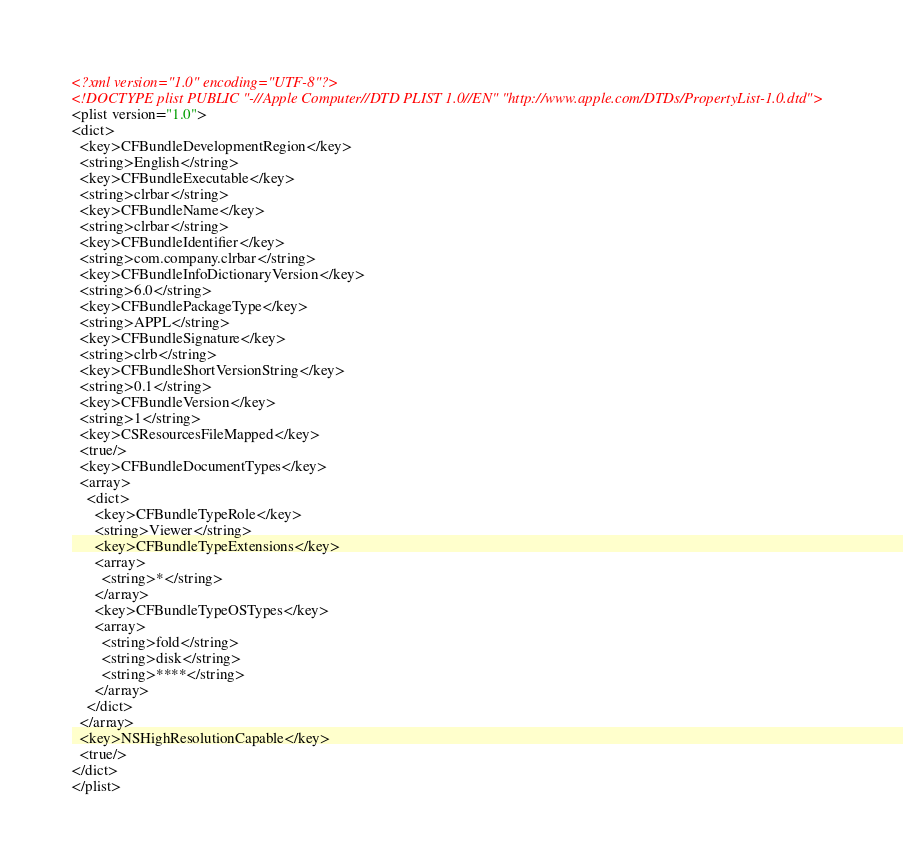Convert code to text. <code><loc_0><loc_0><loc_500><loc_500><_XML_><?xml version="1.0" encoding="UTF-8"?>
<!DOCTYPE plist PUBLIC "-//Apple Computer//DTD PLIST 1.0//EN" "http://www.apple.com/DTDs/PropertyList-1.0.dtd">
<plist version="1.0">
<dict>
  <key>CFBundleDevelopmentRegion</key>
  <string>English</string>
  <key>CFBundleExecutable</key>
  <string>clrbar</string>
  <key>CFBundleName</key>
  <string>clrbar</string>
  <key>CFBundleIdentifier</key>
  <string>com.company.clrbar</string>
  <key>CFBundleInfoDictionaryVersion</key>
  <string>6.0</string>
  <key>CFBundlePackageType</key>
  <string>APPL</string>
  <key>CFBundleSignature</key>
  <string>clrb</string>
  <key>CFBundleShortVersionString</key>
  <string>0.1</string>
  <key>CFBundleVersion</key>
  <string>1</string>
  <key>CSResourcesFileMapped</key>
  <true/>
  <key>CFBundleDocumentTypes</key>
  <array>
    <dict>
      <key>CFBundleTypeRole</key>
      <string>Viewer</string>
      <key>CFBundleTypeExtensions</key>
      <array>
        <string>*</string>
      </array>
      <key>CFBundleTypeOSTypes</key>
      <array>
        <string>fold</string>
        <string>disk</string>
        <string>****</string>
      </array>
    </dict>
  </array>
  <key>NSHighResolutionCapable</key>
  <true/>
</dict>
</plist>
</code> 